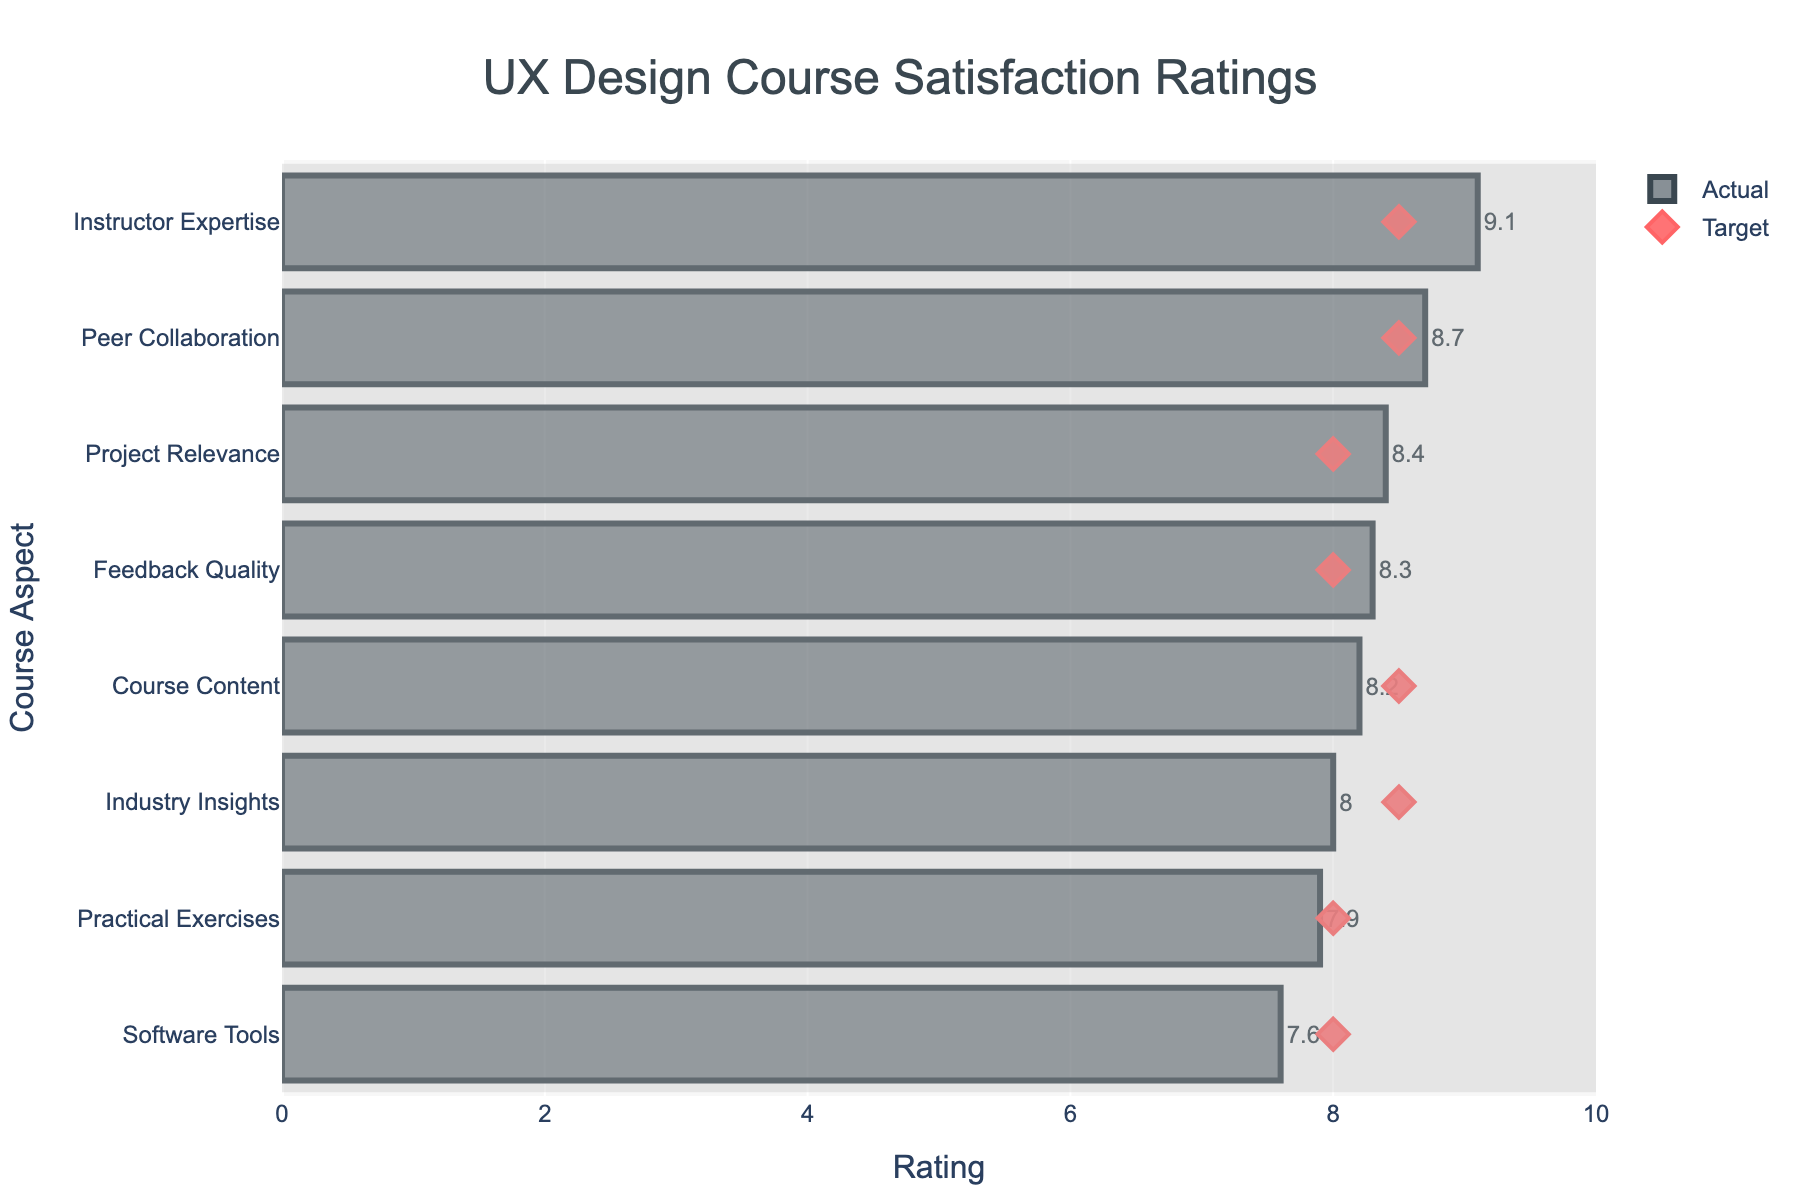How many aspects of the UX design course have actual ratings that meet or exceed their target ratings? Count the number of aspects where the actual rating is greater than or equal to the target rating. In this case, aspects meeting or exceeding their targets are: 'Instructor Expertise' (9.1 vs. 8.5), 'Project Relevance' (8.4 vs. 8.0), 'Peer Collaboration' (8.7 vs. 8.5), and 'Feedback Quality' (8.3 vs. 8.0).
Answer: 4 Among the aspects with actual ratings below their target ratings, which one has the smallest difference from its target? Calculate the difference between actual and target ratings for the aspects where the actual rating is below the target rating: 'Course Content' (8.2 vs. 8.5), 'Practical Exercises' (7.9 vs. 8.0), 'Software Tools' (7.6 vs. 8.0), and 'Industry Insights' (8.0 vs. 8.5). The differences are 0.3, 0.1, 0.4, and 0.5 respectively. The smallest difference is for 'Practical Exercises'.
Answer: Practical Exercises Which aspect received the highest actual satisfaction rating? The aspect with the highest actual rating is identified by looking at the maximum value of the actual ratings: 'Instructor Expertise' received a rating of 9.1.
Answer: Instructor Expertise How many aspects have actual ratings below a score of 8? Count the number of aspects with actual ratings below 8: 'Practical Exercises' (7.9) and 'Software Tools' (7.6).
Answer: 2 What is the average actual satisfaction rating across all course aspects? Sum all actual ratings and divide by the number of aspects: (8.2 + 7.9 + 9.1 + 8.4 + 7.6 + 8.7 + 8.0 + 8.3) / 8. The sum is 66.2, so the average is 66.2 / 8 = 8.275.
Answer: 8.275 